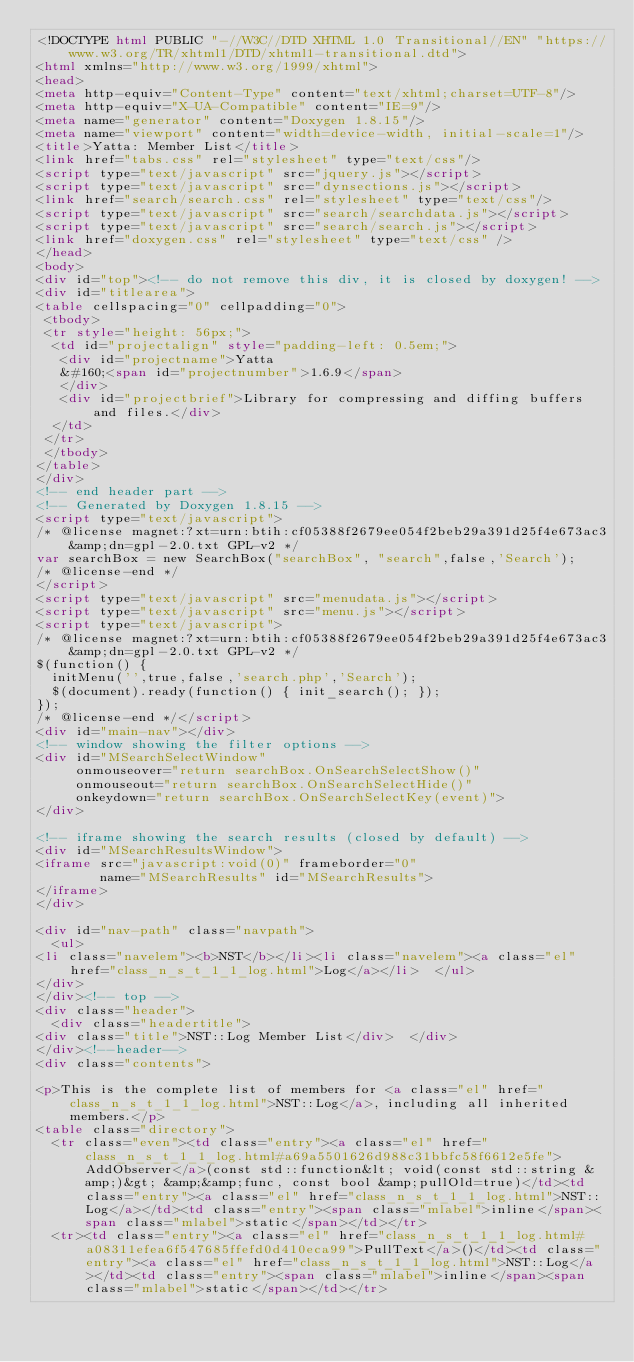Convert code to text. <code><loc_0><loc_0><loc_500><loc_500><_HTML_><!DOCTYPE html PUBLIC "-//W3C//DTD XHTML 1.0 Transitional//EN" "https://www.w3.org/TR/xhtml1/DTD/xhtml1-transitional.dtd">
<html xmlns="http://www.w3.org/1999/xhtml">
<head>
<meta http-equiv="Content-Type" content="text/xhtml;charset=UTF-8"/>
<meta http-equiv="X-UA-Compatible" content="IE=9"/>
<meta name="generator" content="Doxygen 1.8.15"/>
<meta name="viewport" content="width=device-width, initial-scale=1"/>
<title>Yatta: Member List</title>
<link href="tabs.css" rel="stylesheet" type="text/css"/>
<script type="text/javascript" src="jquery.js"></script>
<script type="text/javascript" src="dynsections.js"></script>
<link href="search/search.css" rel="stylesheet" type="text/css"/>
<script type="text/javascript" src="search/searchdata.js"></script>
<script type="text/javascript" src="search/search.js"></script>
<link href="doxygen.css" rel="stylesheet" type="text/css" />
</head>
<body>
<div id="top"><!-- do not remove this div, it is closed by doxygen! -->
<div id="titlearea">
<table cellspacing="0" cellpadding="0">
 <tbody>
 <tr style="height: 56px;">
  <td id="projectalign" style="padding-left: 0.5em;">
   <div id="projectname">Yatta
   &#160;<span id="projectnumber">1.6.9</span>
   </div>
   <div id="projectbrief">Library for compressing and diffing buffers and files.</div>
  </td>
 </tr>
 </tbody>
</table>
</div>
<!-- end header part -->
<!-- Generated by Doxygen 1.8.15 -->
<script type="text/javascript">
/* @license magnet:?xt=urn:btih:cf05388f2679ee054f2beb29a391d25f4e673ac3&amp;dn=gpl-2.0.txt GPL-v2 */
var searchBox = new SearchBox("searchBox", "search",false,'Search');
/* @license-end */
</script>
<script type="text/javascript" src="menudata.js"></script>
<script type="text/javascript" src="menu.js"></script>
<script type="text/javascript">
/* @license magnet:?xt=urn:btih:cf05388f2679ee054f2beb29a391d25f4e673ac3&amp;dn=gpl-2.0.txt GPL-v2 */
$(function() {
  initMenu('',true,false,'search.php','Search');
  $(document).ready(function() { init_search(); });
});
/* @license-end */</script>
<div id="main-nav"></div>
<!-- window showing the filter options -->
<div id="MSearchSelectWindow"
     onmouseover="return searchBox.OnSearchSelectShow()"
     onmouseout="return searchBox.OnSearchSelectHide()"
     onkeydown="return searchBox.OnSearchSelectKey(event)">
</div>

<!-- iframe showing the search results (closed by default) -->
<div id="MSearchResultsWindow">
<iframe src="javascript:void(0)" frameborder="0" 
        name="MSearchResults" id="MSearchResults">
</iframe>
</div>

<div id="nav-path" class="navpath">
  <ul>
<li class="navelem"><b>NST</b></li><li class="navelem"><a class="el" href="class_n_s_t_1_1_log.html">Log</a></li>  </ul>
</div>
</div><!-- top -->
<div class="header">
  <div class="headertitle">
<div class="title">NST::Log Member List</div>  </div>
</div><!--header-->
<div class="contents">

<p>This is the complete list of members for <a class="el" href="class_n_s_t_1_1_log.html">NST::Log</a>, including all inherited members.</p>
<table class="directory">
  <tr class="even"><td class="entry"><a class="el" href="class_n_s_t_1_1_log.html#a69a5501626d988c31bbfc58f6612e5fe">AddObserver</a>(const std::function&lt; void(const std::string &amp;)&gt; &amp;&amp;func, const bool &amp;pullOld=true)</td><td class="entry"><a class="el" href="class_n_s_t_1_1_log.html">NST::Log</a></td><td class="entry"><span class="mlabel">inline</span><span class="mlabel">static</span></td></tr>
  <tr><td class="entry"><a class="el" href="class_n_s_t_1_1_log.html#a08311efea6f547685ffefd0d410eca99">PullText</a>()</td><td class="entry"><a class="el" href="class_n_s_t_1_1_log.html">NST::Log</a></td><td class="entry"><span class="mlabel">inline</span><span class="mlabel">static</span></td></tr></code> 